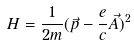<formula> <loc_0><loc_0><loc_500><loc_500>H = \frac { 1 } { 2 m } ( \vec { p } - \frac { e } { c } \vec { A } ) ^ { 2 }</formula> 